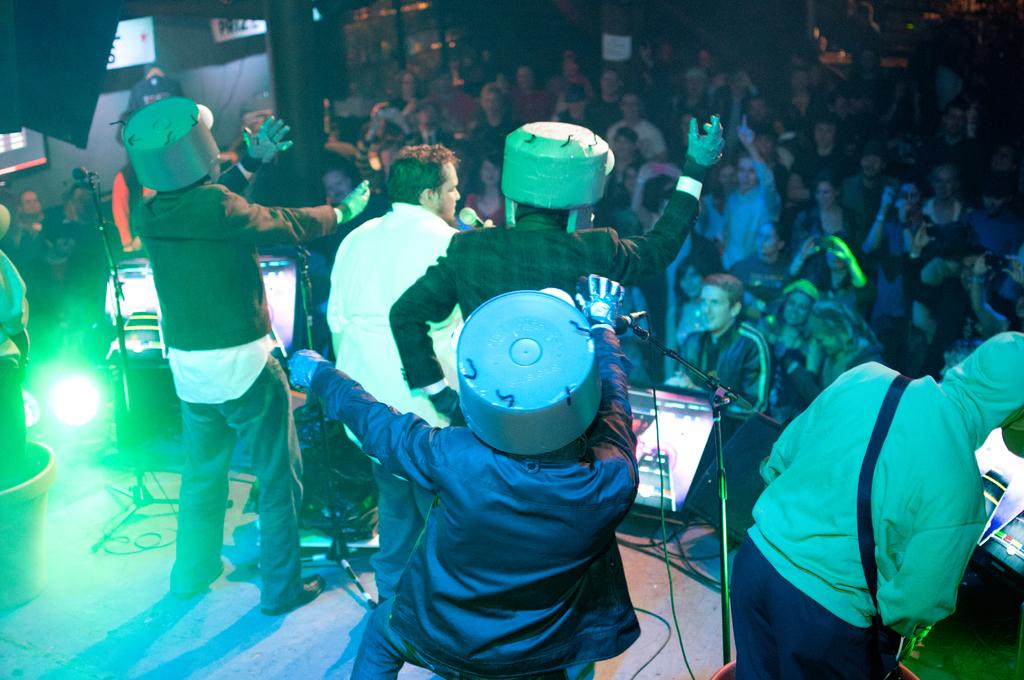How many people are in the image? There is a group of people in the image. Where are some of the people located in the image? Some people are on a stage. What are the people on the stage doing? The people on the stage are musicians. What equipment is in front of the musicians? There are microphones, monitors, and lights in front of the musicians. What type of representative can be seen in the cemetery in the image? There is no representative or cemetery present in the image; it features a group of musicians on a stage. 